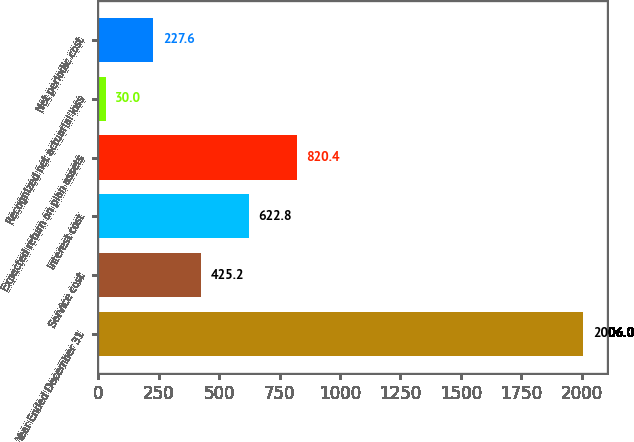Convert chart to OTSL. <chart><loc_0><loc_0><loc_500><loc_500><bar_chart><fcel>Year Ended December 31<fcel>Service cost<fcel>Interest cost<fcel>Expected return on plan assets<fcel>Recognized net actuarial loss<fcel>Net periodic cost<nl><fcel>2006<fcel>425.2<fcel>622.8<fcel>820.4<fcel>30<fcel>227.6<nl></chart> 